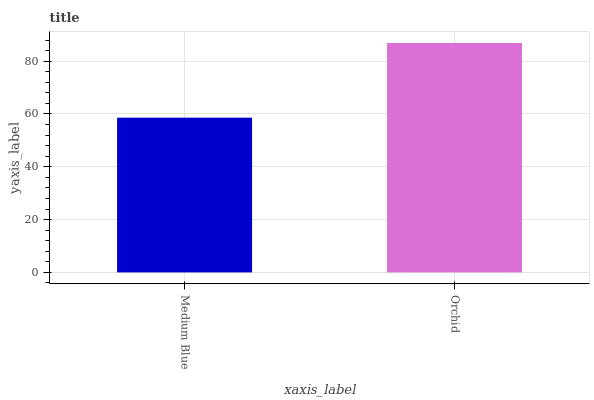Is Medium Blue the minimum?
Answer yes or no. Yes. Is Orchid the maximum?
Answer yes or no. Yes. Is Orchid the minimum?
Answer yes or no. No. Is Orchid greater than Medium Blue?
Answer yes or no. Yes. Is Medium Blue less than Orchid?
Answer yes or no. Yes. Is Medium Blue greater than Orchid?
Answer yes or no. No. Is Orchid less than Medium Blue?
Answer yes or no. No. Is Orchid the high median?
Answer yes or no. Yes. Is Medium Blue the low median?
Answer yes or no. Yes. Is Medium Blue the high median?
Answer yes or no. No. Is Orchid the low median?
Answer yes or no. No. 